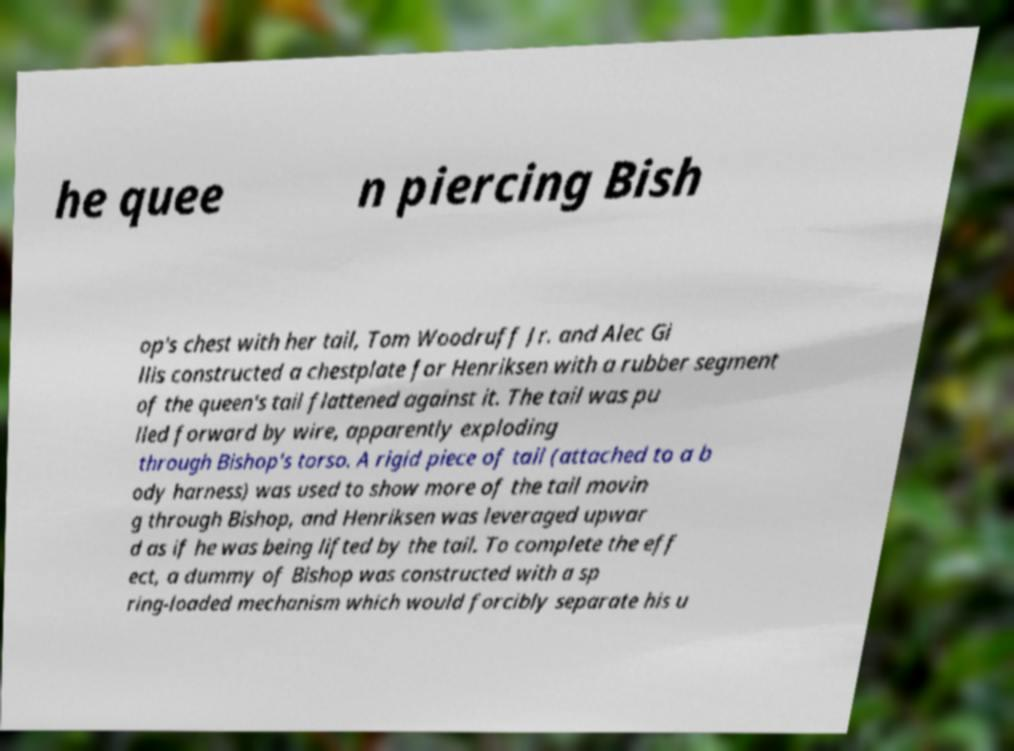Could you extract and type out the text from this image? he quee n piercing Bish op's chest with her tail, Tom Woodruff Jr. and Alec Gi llis constructed a chestplate for Henriksen with a rubber segment of the queen's tail flattened against it. The tail was pu lled forward by wire, apparently exploding through Bishop's torso. A rigid piece of tail (attached to a b ody harness) was used to show more of the tail movin g through Bishop, and Henriksen was leveraged upwar d as if he was being lifted by the tail. To complete the eff ect, a dummy of Bishop was constructed with a sp ring-loaded mechanism which would forcibly separate his u 